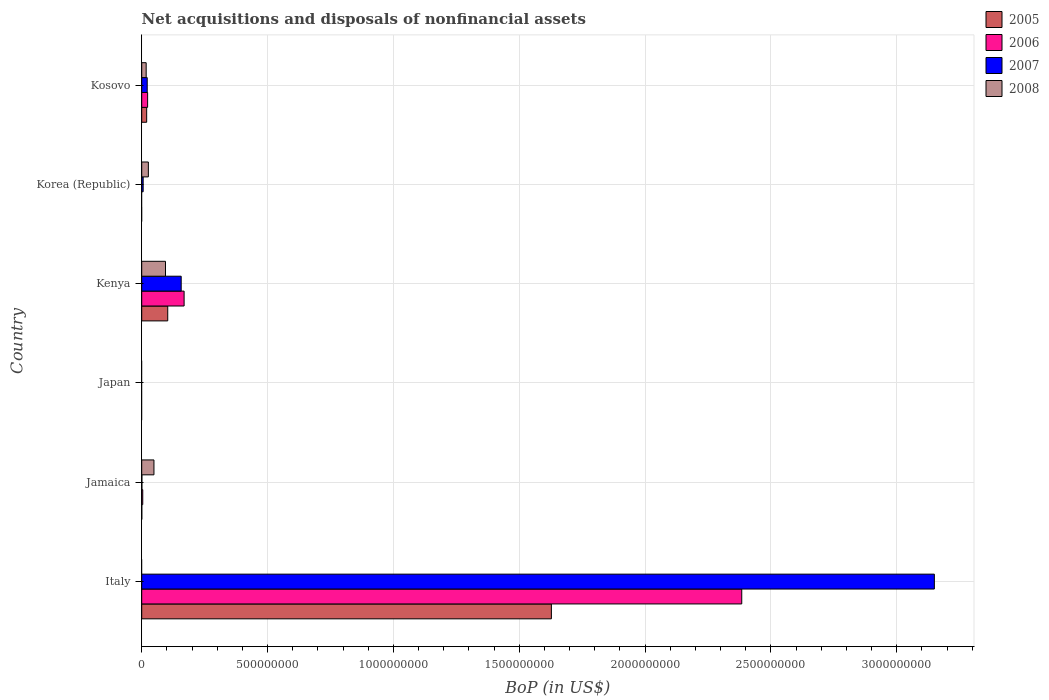Are the number of bars per tick equal to the number of legend labels?
Provide a short and direct response. No. Are the number of bars on each tick of the Y-axis equal?
Your answer should be compact. No. What is the label of the 1st group of bars from the top?
Your answer should be compact. Kosovo. In how many cases, is the number of bars for a given country not equal to the number of legend labels?
Offer a terse response. 3. What is the Balance of Payments in 2005 in Kenya?
Your answer should be compact. 1.03e+08. Across all countries, what is the maximum Balance of Payments in 2005?
Your answer should be compact. 1.63e+09. Across all countries, what is the minimum Balance of Payments in 2007?
Your response must be concise. 0. In which country was the Balance of Payments in 2005 maximum?
Provide a short and direct response. Italy. What is the total Balance of Payments in 2008 in the graph?
Make the answer very short. 1.87e+08. What is the difference between the Balance of Payments in 2006 in Italy and that in Kosovo?
Offer a terse response. 2.36e+09. What is the difference between the Balance of Payments in 2005 in Italy and the Balance of Payments in 2007 in Kenya?
Offer a terse response. 1.47e+09. What is the average Balance of Payments in 2008 per country?
Give a very brief answer. 3.12e+07. What is the difference between the Balance of Payments in 2005 and Balance of Payments in 2007 in Italy?
Make the answer very short. -1.52e+09. In how many countries, is the Balance of Payments in 2008 greater than 2300000000 US$?
Your response must be concise. 0. What is the ratio of the Balance of Payments in 2008 in Kenya to that in Kosovo?
Keep it short and to the point. 5.35. What is the difference between the highest and the second highest Balance of Payments in 2005?
Give a very brief answer. 1.52e+09. What is the difference between the highest and the lowest Balance of Payments in 2006?
Offer a very short reply. 2.38e+09. Is it the case that in every country, the sum of the Balance of Payments in 2005 and Balance of Payments in 2006 is greater than the sum of Balance of Payments in 2008 and Balance of Payments in 2007?
Keep it short and to the point. No. How many bars are there?
Make the answer very short. 17. Are all the bars in the graph horizontal?
Provide a succinct answer. Yes. Are the values on the major ticks of X-axis written in scientific E-notation?
Your answer should be compact. No. Does the graph contain grids?
Your response must be concise. Yes. What is the title of the graph?
Your answer should be very brief. Net acquisitions and disposals of nonfinancial assets. What is the label or title of the X-axis?
Provide a short and direct response. BoP (in US$). What is the label or title of the Y-axis?
Your response must be concise. Country. What is the BoP (in US$) of 2005 in Italy?
Give a very brief answer. 1.63e+09. What is the BoP (in US$) in 2006 in Italy?
Make the answer very short. 2.38e+09. What is the BoP (in US$) in 2007 in Italy?
Offer a terse response. 3.15e+09. What is the BoP (in US$) of 2005 in Jamaica?
Give a very brief answer. 3.00e+05. What is the BoP (in US$) in 2006 in Jamaica?
Your answer should be very brief. 4.09e+06. What is the BoP (in US$) of 2007 in Jamaica?
Make the answer very short. 6.90e+05. What is the BoP (in US$) in 2008 in Jamaica?
Give a very brief answer. 4.86e+07. What is the BoP (in US$) in 2005 in Japan?
Provide a short and direct response. 0. What is the BoP (in US$) in 2005 in Kenya?
Your response must be concise. 1.03e+08. What is the BoP (in US$) in 2006 in Kenya?
Give a very brief answer. 1.68e+08. What is the BoP (in US$) of 2007 in Kenya?
Your answer should be compact. 1.57e+08. What is the BoP (in US$) in 2008 in Kenya?
Your answer should be very brief. 9.45e+07. What is the BoP (in US$) in 2006 in Korea (Republic)?
Provide a succinct answer. 0. What is the BoP (in US$) in 2007 in Korea (Republic)?
Provide a succinct answer. 5.70e+06. What is the BoP (in US$) in 2008 in Korea (Republic)?
Offer a very short reply. 2.64e+07. What is the BoP (in US$) of 2005 in Kosovo?
Your answer should be very brief. 1.96e+07. What is the BoP (in US$) of 2006 in Kosovo?
Your answer should be very brief. 2.35e+07. What is the BoP (in US$) in 2007 in Kosovo?
Your response must be concise. 2.19e+07. What is the BoP (in US$) of 2008 in Kosovo?
Give a very brief answer. 1.77e+07. Across all countries, what is the maximum BoP (in US$) of 2005?
Your answer should be compact. 1.63e+09. Across all countries, what is the maximum BoP (in US$) in 2006?
Provide a succinct answer. 2.38e+09. Across all countries, what is the maximum BoP (in US$) of 2007?
Give a very brief answer. 3.15e+09. Across all countries, what is the maximum BoP (in US$) in 2008?
Offer a very short reply. 9.45e+07. Across all countries, what is the minimum BoP (in US$) in 2005?
Keep it short and to the point. 0. Across all countries, what is the minimum BoP (in US$) in 2007?
Keep it short and to the point. 0. What is the total BoP (in US$) in 2005 in the graph?
Give a very brief answer. 1.75e+09. What is the total BoP (in US$) of 2006 in the graph?
Give a very brief answer. 2.58e+09. What is the total BoP (in US$) in 2007 in the graph?
Your answer should be compact. 3.33e+09. What is the total BoP (in US$) of 2008 in the graph?
Your response must be concise. 1.87e+08. What is the difference between the BoP (in US$) in 2005 in Italy and that in Jamaica?
Your answer should be very brief. 1.63e+09. What is the difference between the BoP (in US$) of 2006 in Italy and that in Jamaica?
Your response must be concise. 2.38e+09. What is the difference between the BoP (in US$) in 2007 in Italy and that in Jamaica?
Keep it short and to the point. 3.15e+09. What is the difference between the BoP (in US$) of 2005 in Italy and that in Kenya?
Offer a very short reply. 1.52e+09. What is the difference between the BoP (in US$) in 2006 in Italy and that in Kenya?
Provide a succinct answer. 2.22e+09. What is the difference between the BoP (in US$) in 2007 in Italy and that in Kenya?
Provide a succinct answer. 2.99e+09. What is the difference between the BoP (in US$) of 2007 in Italy and that in Korea (Republic)?
Keep it short and to the point. 3.14e+09. What is the difference between the BoP (in US$) of 2005 in Italy and that in Kosovo?
Your answer should be compact. 1.61e+09. What is the difference between the BoP (in US$) of 2006 in Italy and that in Kosovo?
Your response must be concise. 2.36e+09. What is the difference between the BoP (in US$) of 2007 in Italy and that in Kosovo?
Ensure brevity in your answer.  3.13e+09. What is the difference between the BoP (in US$) in 2005 in Jamaica and that in Kenya?
Make the answer very short. -1.03e+08. What is the difference between the BoP (in US$) in 2006 in Jamaica and that in Kenya?
Make the answer very short. -1.64e+08. What is the difference between the BoP (in US$) in 2007 in Jamaica and that in Kenya?
Provide a short and direct response. -1.56e+08. What is the difference between the BoP (in US$) in 2008 in Jamaica and that in Kenya?
Provide a succinct answer. -4.59e+07. What is the difference between the BoP (in US$) of 2007 in Jamaica and that in Korea (Republic)?
Ensure brevity in your answer.  -5.01e+06. What is the difference between the BoP (in US$) in 2008 in Jamaica and that in Korea (Republic)?
Ensure brevity in your answer.  2.22e+07. What is the difference between the BoP (in US$) in 2005 in Jamaica and that in Kosovo?
Your response must be concise. -1.93e+07. What is the difference between the BoP (in US$) in 2006 in Jamaica and that in Kosovo?
Provide a short and direct response. -1.94e+07. What is the difference between the BoP (in US$) in 2007 in Jamaica and that in Kosovo?
Give a very brief answer. -2.12e+07. What is the difference between the BoP (in US$) in 2008 in Jamaica and that in Kosovo?
Your answer should be compact. 3.09e+07. What is the difference between the BoP (in US$) of 2007 in Kenya and that in Korea (Republic)?
Give a very brief answer. 1.51e+08. What is the difference between the BoP (in US$) of 2008 in Kenya and that in Korea (Republic)?
Provide a succinct answer. 6.81e+07. What is the difference between the BoP (in US$) of 2005 in Kenya and that in Kosovo?
Provide a succinct answer. 8.37e+07. What is the difference between the BoP (in US$) in 2006 in Kenya and that in Kosovo?
Your answer should be compact. 1.45e+08. What is the difference between the BoP (in US$) in 2007 in Kenya and that in Kosovo?
Give a very brief answer. 1.35e+08. What is the difference between the BoP (in US$) in 2008 in Kenya and that in Kosovo?
Provide a short and direct response. 7.68e+07. What is the difference between the BoP (in US$) in 2007 in Korea (Republic) and that in Kosovo?
Offer a very short reply. -1.62e+07. What is the difference between the BoP (in US$) of 2008 in Korea (Republic) and that in Kosovo?
Offer a terse response. 8.73e+06. What is the difference between the BoP (in US$) in 2005 in Italy and the BoP (in US$) in 2006 in Jamaica?
Your response must be concise. 1.62e+09. What is the difference between the BoP (in US$) of 2005 in Italy and the BoP (in US$) of 2007 in Jamaica?
Provide a succinct answer. 1.63e+09. What is the difference between the BoP (in US$) of 2005 in Italy and the BoP (in US$) of 2008 in Jamaica?
Provide a succinct answer. 1.58e+09. What is the difference between the BoP (in US$) in 2006 in Italy and the BoP (in US$) in 2007 in Jamaica?
Offer a very short reply. 2.38e+09. What is the difference between the BoP (in US$) in 2006 in Italy and the BoP (in US$) in 2008 in Jamaica?
Offer a terse response. 2.34e+09. What is the difference between the BoP (in US$) in 2007 in Italy and the BoP (in US$) in 2008 in Jamaica?
Ensure brevity in your answer.  3.10e+09. What is the difference between the BoP (in US$) in 2005 in Italy and the BoP (in US$) in 2006 in Kenya?
Give a very brief answer. 1.46e+09. What is the difference between the BoP (in US$) of 2005 in Italy and the BoP (in US$) of 2007 in Kenya?
Your response must be concise. 1.47e+09. What is the difference between the BoP (in US$) of 2005 in Italy and the BoP (in US$) of 2008 in Kenya?
Your answer should be very brief. 1.53e+09. What is the difference between the BoP (in US$) of 2006 in Italy and the BoP (in US$) of 2007 in Kenya?
Make the answer very short. 2.23e+09. What is the difference between the BoP (in US$) in 2006 in Italy and the BoP (in US$) in 2008 in Kenya?
Your response must be concise. 2.29e+09. What is the difference between the BoP (in US$) of 2007 in Italy and the BoP (in US$) of 2008 in Kenya?
Provide a short and direct response. 3.05e+09. What is the difference between the BoP (in US$) of 2005 in Italy and the BoP (in US$) of 2007 in Korea (Republic)?
Your answer should be compact. 1.62e+09. What is the difference between the BoP (in US$) in 2005 in Italy and the BoP (in US$) in 2008 in Korea (Republic)?
Provide a short and direct response. 1.60e+09. What is the difference between the BoP (in US$) in 2006 in Italy and the BoP (in US$) in 2007 in Korea (Republic)?
Keep it short and to the point. 2.38e+09. What is the difference between the BoP (in US$) of 2006 in Italy and the BoP (in US$) of 2008 in Korea (Republic)?
Your answer should be very brief. 2.36e+09. What is the difference between the BoP (in US$) of 2007 in Italy and the BoP (in US$) of 2008 in Korea (Republic)?
Provide a short and direct response. 3.12e+09. What is the difference between the BoP (in US$) of 2005 in Italy and the BoP (in US$) of 2006 in Kosovo?
Keep it short and to the point. 1.60e+09. What is the difference between the BoP (in US$) of 2005 in Italy and the BoP (in US$) of 2007 in Kosovo?
Give a very brief answer. 1.61e+09. What is the difference between the BoP (in US$) of 2005 in Italy and the BoP (in US$) of 2008 in Kosovo?
Your answer should be compact. 1.61e+09. What is the difference between the BoP (in US$) of 2006 in Italy and the BoP (in US$) of 2007 in Kosovo?
Keep it short and to the point. 2.36e+09. What is the difference between the BoP (in US$) of 2006 in Italy and the BoP (in US$) of 2008 in Kosovo?
Give a very brief answer. 2.37e+09. What is the difference between the BoP (in US$) of 2007 in Italy and the BoP (in US$) of 2008 in Kosovo?
Keep it short and to the point. 3.13e+09. What is the difference between the BoP (in US$) in 2005 in Jamaica and the BoP (in US$) in 2006 in Kenya?
Your answer should be compact. -1.68e+08. What is the difference between the BoP (in US$) in 2005 in Jamaica and the BoP (in US$) in 2007 in Kenya?
Your answer should be compact. -1.57e+08. What is the difference between the BoP (in US$) of 2005 in Jamaica and the BoP (in US$) of 2008 in Kenya?
Provide a short and direct response. -9.42e+07. What is the difference between the BoP (in US$) of 2006 in Jamaica and the BoP (in US$) of 2007 in Kenya?
Offer a very short reply. -1.53e+08. What is the difference between the BoP (in US$) in 2006 in Jamaica and the BoP (in US$) in 2008 in Kenya?
Provide a short and direct response. -9.04e+07. What is the difference between the BoP (in US$) of 2007 in Jamaica and the BoP (in US$) of 2008 in Kenya?
Your response must be concise. -9.38e+07. What is the difference between the BoP (in US$) of 2005 in Jamaica and the BoP (in US$) of 2007 in Korea (Republic)?
Offer a very short reply. -5.40e+06. What is the difference between the BoP (in US$) of 2005 in Jamaica and the BoP (in US$) of 2008 in Korea (Republic)?
Give a very brief answer. -2.61e+07. What is the difference between the BoP (in US$) of 2006 in Jamaica and the BoP (in US$) of 2007 in Korea (Republic)?
Make the answer very short. -1.61e+06. What is the difference between the BoP (in US$) of 2006 in Jamaica and the BoP (in US$) of 2008 in Korea (Republic)?
Offer a terse response. -2.23e+07. What is the difference between the BoP (in US$) of 2007 in Jamaica and the BoP (in US$) of 2008 in Korea (Republic)?
Your answer should be very brief. -2.57e+07. What is the difference between the BoP (in US$) in 2005 in Jamaica and the BoP (in US$) in 2006 in Kosovo?
Offer a very short reply. -2.32e+07. What is the difference between the BoP (in US$) of 2005 in Jamaica and the BoP (in US$) of 2007 in Kosovo?
Provide a succinct answer. -2.16e+07. What is the difference between the BoP (in US$) of 2005 in Jamaica and the BoP (in US$) of 2008 in Kosovo?
Make the answer very short. -1.74e+07. What is the difference between the BoP (in US$) in 2006 in Jamaica and the BoP (in US$) in 2007 in Kosovo?
Give a very brief answer. -1.78e+07. What is the difference between the BoP (in US$) of 2006 in Jamaica and the BoP (in US$) of 2008 in Kosovo?
Offer a terse response. -1.36e+07. What is the difference between the BoP (in US$) in 2007 in Jamaica and the BoP (in US$) in 2008 in Kosovo?
Provide a short and direct response. -1.70e+07. What is the difference between the BoP (in US$) in 2005 in Kenya and the BoP (in US$) in 2007 in Korea (Republic)?
Provide a short and direct response. 9.76e+07. What is the difference between the BoP (in US$) in 2005 in Kenya and the BoP (in US$) in 2008 in Korea (Republic)?
Keep it short and to the point. 7.69e+07. What is the difference between the BoP (in US$) in 2006 in Kenya and the BoP (in US$) in 2007 in Korea (Republic)?
Provide a succinct answer. 1.63e+08. What is the difference between the BoP (in US$) of 2006 in Kenya and the BoP (in US$) of 2008 in Korea (Republic)?
Provide a short and direct response. 1.42e+08. What is the difference between the BoP (in US$) in 2007 in Kenya and the BoP (in US$) in 2008 in Korea (Republic)?
Offer a very short reply. 1.30e+08. What is the difference between the BoP (in US$) in 2005 in Kenya and the BoP (in US$) in 2006 in Kosovo?
Make the answer very short. 7.99e+07. What is the difference between the BoP (in US$) of 2005 in Kenya and the BoP (in US$) of 2007 in Kosovo?
Provide a succinct answer. 8.15e+07. What is the difference between the BoP (in US$) in 2005 in Kenya and the BoP (in US$) in 2008 in Kosovo?
Give a very brief answer. 8.57e+07. What is the difference between the BoP (in US$) in 2006 in Kenya and the BoP (in US$) in 2007 in Kosovo?
Your answer should be very brief. 1.47e+08. What is the difference between the BoP (in US$) of 2006 in Kenya and the BoP (in US$) of 2008 in Kosovo?
Your response must be concise. 1.51e+08. What is the difference between the BoP (in US$) in 2007 in Kenya and the BoP (in US$) in 2008 in Kosovo?
Your answer should be very brief. 1.39e+08. What is the difference between the BoP (in US$) in 2007 in Korea (Republic) and the BoP (in US$) in 2008 in Kosovo?
Your response must be concise. -1.20e+07. What is the average BoP (in US$) of 2005 per country?
Provide a short and direct response. 2.92e+08. What is the average BoP (in US$) of 2006 per country?
Keep it short and to the point. 4.30e+08. What is the average BoP (in US$) in 2007 per country?
Ensure brevity in your answer.  5.56e+08. What is the average BoP (in US$) in 2008 per country?
Provide a succinct answer. 3.12e+07. What is the difference between the BoP (in US$) in 2005 and BoP (in US$) in 2006 in Italy?
Your answer should be compact. -7.56e+08. What is the difference between the BoP (in US$) of 2005 and BoP (in US$) of 2007 in Italy?
Offer a very short reply. -1.52e+09. What is the difference between the BoP (in US$) in 2006 and BoP (in US$) in 2007 in Italy?
Give a very brief answer. -7.65e+08. What is the difference between the BoP (in US$) in 2005 and BoP (in US$) in 2006 in Jamaica?
Offer a very short reply. -3.79e+06. What is the difference between the BoP (in US$) of 2005 and BoP (in US$) of 2007 in Jamaica?
Ensure brevity in your answer.  -3.90e+05. What is the difference between the BoP (in US$) of 2005 and BoP (in US$) of 2008 in Jamaica?
Offer a very short reply. -4.83e+07. What is the difference between the BoP (in US$) in 2006 and BoP (in US$) in 2007 in Jamaica?
Ensure brevity in your answer.  3.40e+06. What is the difference between the BoP (in US$) of 2006 and BoP (in US$) of 2008 in Jamaica?
Keep it short and to the point. -4.45e+07. What is the difference between the BoP (in US$) in 2007 and BoP (in US$) in 2008 in Jamaica?
Offer a terse response. -4.79e+07. What is the difference between the BoP (in US$) of 2005 and BoP (in US$) of 2006 in Kenya?
Provide a short and direct response. -6.51e+07. What is the difference between the BoP (in US$) in 2005 and BoP (in US$) in 2007 in Kenya?
Offer a very short reply. -5.35e+07. What is the difference between the BoP (in US$) in 2005 and BoP (in US$) in 2008 in Kenya?
Offer a very short reply. 8.86e+06. What is the difference between the BoP (in US$) of 2006 and BoP (in US$) of 2007 in Kenya?
Your response must be concise. 1.16e+07. What is the difference between the BoP (in US$) of 2006 and BoP (in US$) of 2008 in Kenya?
Provide a succinct answer. 7.39e+07. What is the difference between the BoP (in US$) of 2007 and BoP (in US$) of 2008 in Kenya?
Ensure brevity in your answer.  6.24e+07. What is the difference between the BoP (in US$) of 2007 and BoP (in US$) of 2008 in Korea (Republic)?
Give a very brief answer. -2.07e+07. What is the difference between the BoP (in US$) in 2005 and BoP (in US$) in 2006 in Kosovo?
Make the answer very short. -3.81e+06. What is the difference between the BoP (in US$) in 2005 and BoP (in US$) in 2007 in Kosovo?
Make the answer very short. -2.21e+06. What is the difference between the BoP (in US$) of 2005 and BoP (in US$) of 2008 in Kosovo?
Provide a succinct answer. 1.97e+06. What is the difference between the BoP (in US$) in 2006 and BoP (in US$) in 2007 in Kosovo?
Your answer should be very brief. 1.60e+06. What is the difference between the BoP (in US$) of 2006 and BoP (in US$) of 2008 in Kosovo?
Your answer should be very brief. 5.78e+06. What is the difference between the BoP (in US$) in 2007 and BoP (in US$) in 2008 in Kosovo?
Offer a terse response. 4.18e+06. What is the ratio of the BoP (in US$) in 2005 in Italy to that in Jamaica?
Offer a terse response. 5425.92. What is the ratio of the BoP (in US$) of 2006 in Italy to that in Jamaica?
Your response must be concise. 582.91. What is the ratio of the BoP (in US$) in 2007 in Italy to that in Jamaica?
Ensure brevity in your answer.  4564.42. What is the ratio of the BoP (in US$) in 2005 in Italy to that in Kenya?
Offer a terse response. 15.75. What is the ratio of the BoP (in US$) of 2006 in Italy to that in Kenya?
Offer a very short reply. 14.16. What is the ratio of the BoP (in US$) of 2007 in Italy to that in Kenya?
Make the answer very short. 20.08. What is the ratio of the BoP (in US$) of 2007 in Italy to that in Korea (Republic)?
Ensure brevity in your answer.  552.54. What is the ratio of the BoP (in US$) in 2005 in Italy to that in Kosovo?
Your response must be concise. 82.85. What is the ratio of the BoP (in US$) in 2006 in Italy to that in Kosovo?
Your answer should be compact. 101.64. What is the ratio of the BoP (in US$) in 2007 in Italy to that in Kosovo?
Provide a succinct answer. 144.09. What is the ratio of the BoP (in US$) in 2005 in Jamaica to that in Kenya?
Provide a short and direct response. 0. What is the ratio of the BoP (in US$) in 2006 in Jamaica to that in Kenya?
Your answer should be very brief. 0.02. What is the ratio of the BoP (in US$) of 2007 in Jamaica to that in Kenya?
Give a very brief answer. 0. What is the ratio of the BoP (in US$) of 2008 in Jamaica to that in Kenya?
Make the answer very short. 0.51. What is the ratio of the BoP (in US$) in 2007 in Jamaica to that in Korea (Republic)?
Provide a succinct answer. 0.12. What is the ratio of the BoP (in US$) of 2008 in Jamaica to that in Korea (Republic)?
Provide a succinct answer. 1.84. What is the ratio of the BoP (in US$) of 2005 in Jamaica to that in Kosovo?
Your answer should be compact. 0.02. What is the ratio of the BoP (in US$) of 2006 in Jamaica to that in Kosovo?
Keep it short and to the point. 0.17. What is the ratio of the BoP (in US$) of 2007 in Jamaica to that in Kosovo?
Offer a very short reply. 0.03. What is the ratio of the BoP (in US$) in 2008 in Jamaica to that in Kosovo?
Keep it short and to the point. 2.75. What is the ratio of the BoP (in US$) in 2007 in Kenya to that in Korea (Republic)?
Ensure brevity in your answer.  27.52. What is the ratio of the BoP (in US$) in 2008 in Kenya to that in Korea (Republic)?
Make the answer very short. 3.58. What is the ratio of the BoP (in US$) in 2005 in Kenya to that in Kosovo?
Your response must be concise. 5.26. What is the ratio of the BoP (in US$) in 2006 in Kenya to that in Kosovo?
Provide a succinct answer. 7.18. What is the ratio of the BoP (in US$) of 2007 in Kenya to that in Kosovo?
Make the answer very short. 7.18. What is the ratio of the BoP (in US$) of 2008 in Kenya to that in Kosovo?
Offer a terse response. 5.35. What is the ratio of the BoP (in US$) in 2007 in Korea (Republic) to that in Kosovo?
Make the answer very short. 0.26. What is the ratio of the BoP (in US$) of 2008 in Korea (Republic) to that in Kosovo?
Make the answer very short. 1.49. What is the difference between the highest and the second highest BoP (in US$) of 2005?
Your answer should be compact. 1.52e+09. What is the difference between the highest and the second highest BoP (in US$) in 2006?
Keep it short and to the point. 2.22e+09. What is the difference between the highest and the second highest BoP (in US$) of 2007?
Offer a terse response. 2.99e+09. What is the difference between the highest and the second highest BoP (in US$) of 2008?
Give a very brief answer. 4.59e+07. What is the difference between the highest and the lowest BoP (in US$) in 2005?
Make the answer very short. 1.63e+09. What is the difference between the highest and the lowest BoP (in US$) of 2006?
Provide a short and direct response. 2.38e+09. What is the difference between the highest and the lowest BoP (in US$) in 2007?
Provide a succinct answer. 3.15e+09. What is the difference between the highest and the lowest BoP (in US$) in 2008?
Provide a succinct answer. 9.45e+07. 